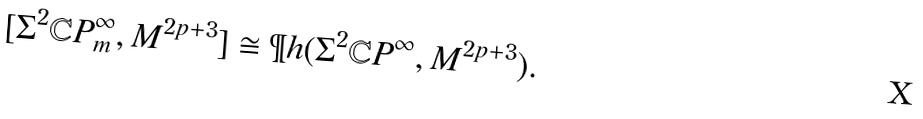<formula> <loc_0><loc_0><loc_500><loc_500>[ \Sigma ^ { 2 } \mathbb { C } P ^ { \infty } _ { m } , M ^ { 2 p + 3 } ] \cong \P h ( \Sigma ^ { 2 } \mathbb { C } P ^ { \infty } , M ^ { 2 p + 3 } ) .</formula> 